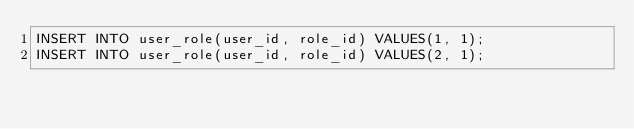<code> <loc_0><loc_0><loc_500><loc_500><_SQL_>INSERT INTO user_role(user_id, role_id) VALUES(1, 1);
INSERT INTO user_role(user_id, role_id) VALUES(2, 1);</code> 